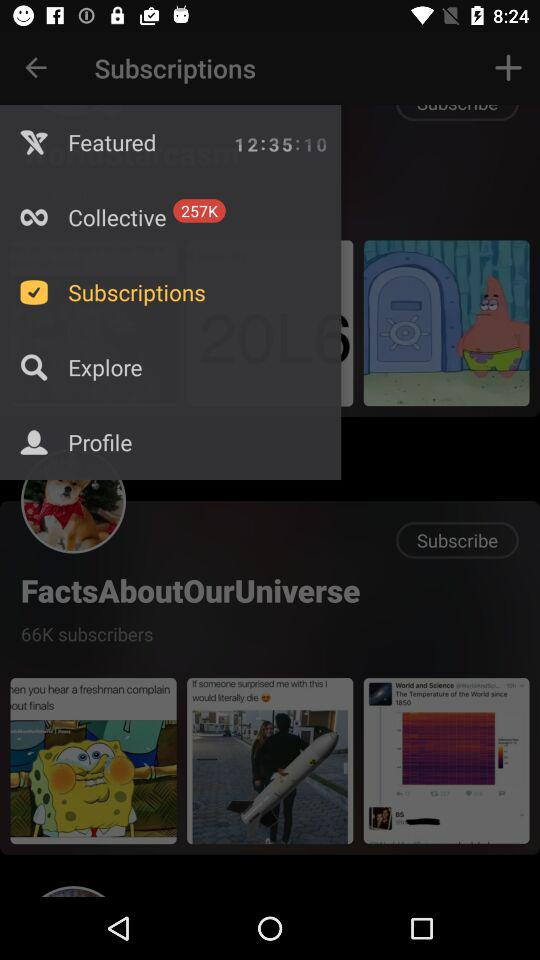How many subscribers are shown here? The shown subscribers are 66K. 